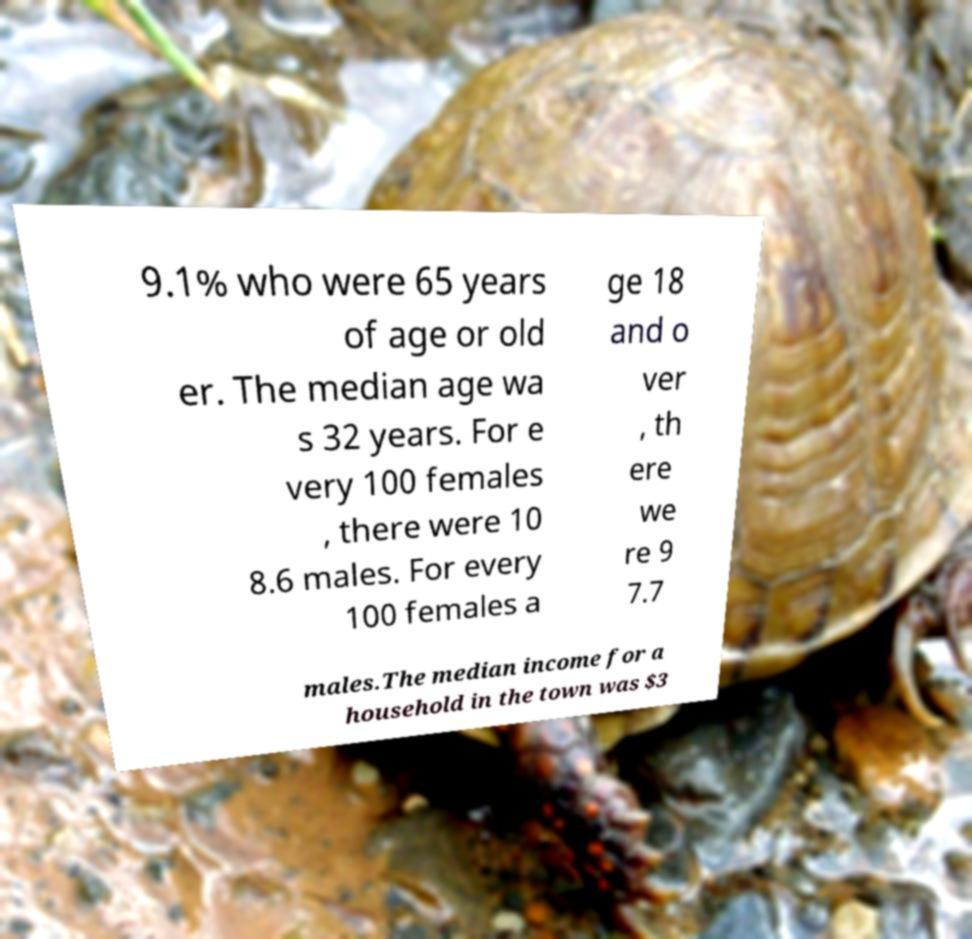Could you assist in decoding the text presented in this image and type it out clearly? 9.1% who were 65 years of age or old er. The median age wa s 32 years. For e very 100 females , there were 10 8.6 males. For every 100 females a ge 18 and o ver , th ere we re 9 7.7 males.The median income for a household in the town was $3 